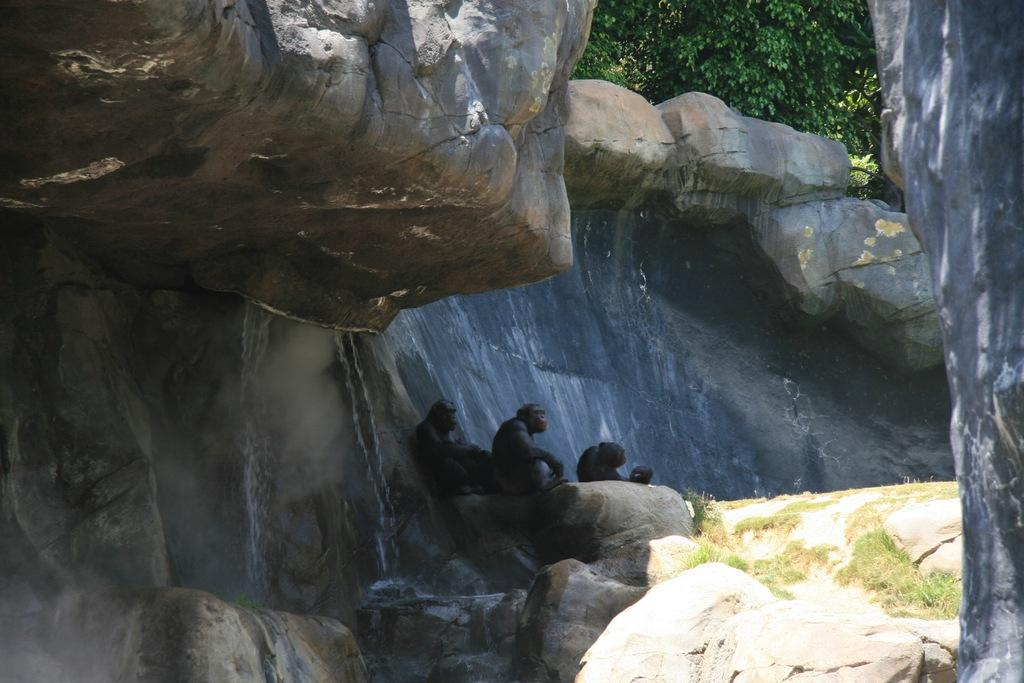What animals are sitting on a rock in the image? There are monkeys sitting on a rock in the image. What type of vegetation can be seen in the image? There are trees and grass visible in the image. What type of veil is being used by the monkeys in the image? There is no veil present in the image; the monkeys are not wearing or using any veils. 